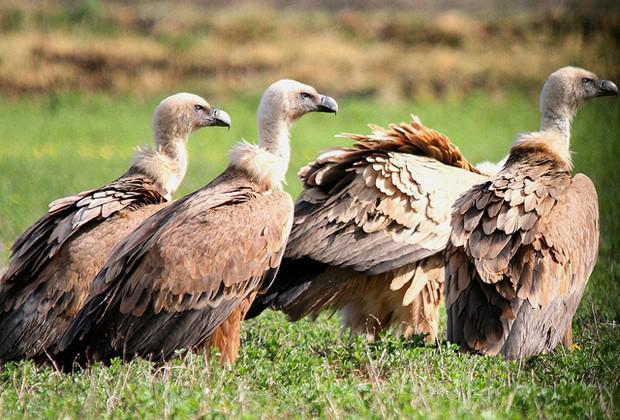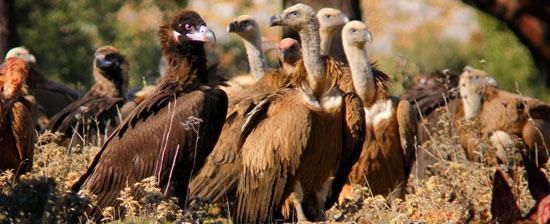The first image is the image on the left, the second image is the image on the right. Assess this claim about the two images: "In at least one image there are four vultures.". Correct or not? Answer yes or no. Yes. The first image is the image on the left, the second image is the image on the right. For the images shown, is this caption "One of the images shows four vultures, while the other shows many more, and none of them are currently eating." true? Answer yes or no. Yes. 